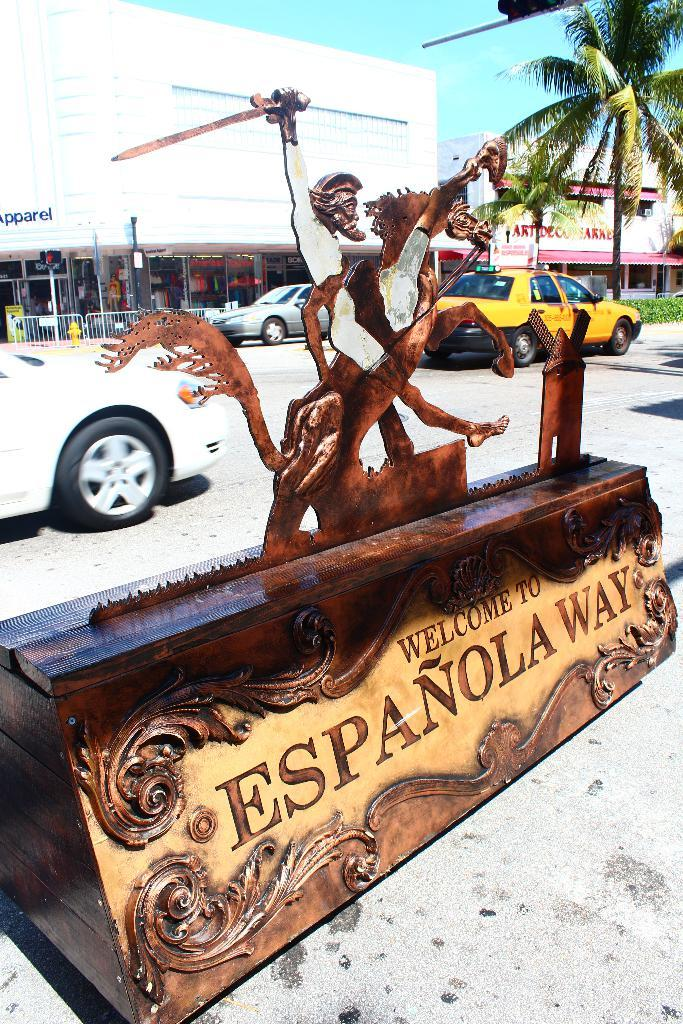<image>
Offer a succinct explanation of the picture presented. A sign in a parking lot says "Welcome to Española Way." 